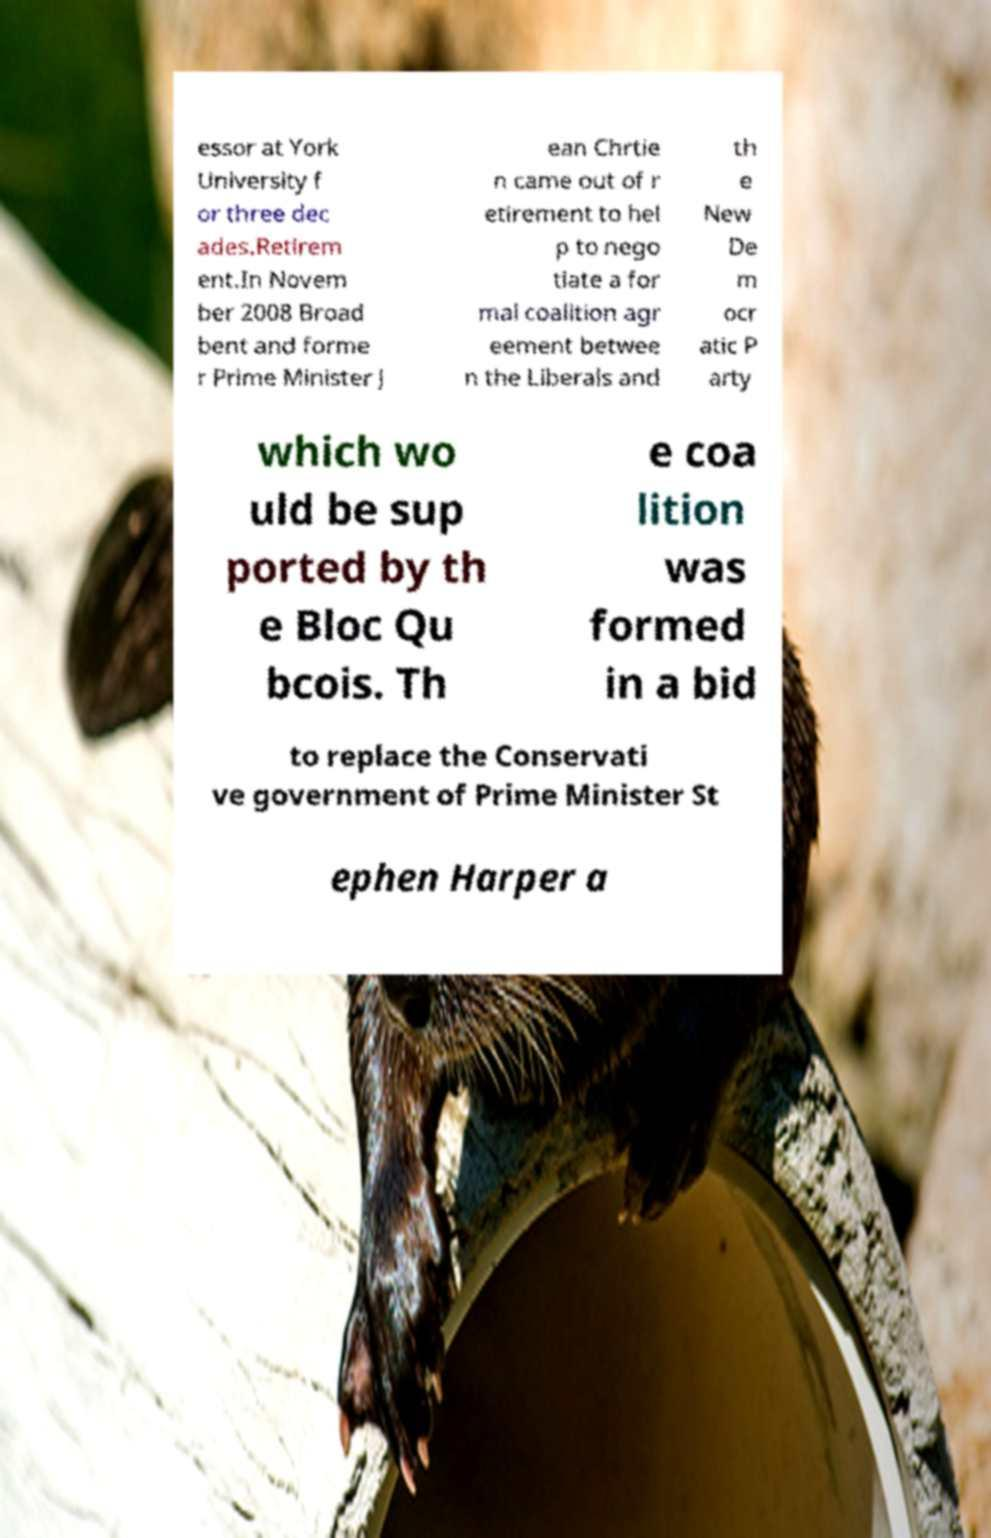There's text embedded in this image that I need extracted. Can you transcribe it verbatim? essor at York University f or three dec ades.Retirem ent.In Novem ber 2008 Broad bent and forme r Prime Minister J ean Chrtie n came out of r etirement to hel p to nego tiate a for mal coalition agr eement betwee n the Liberals and th e New De m ocr atic P arty which wo uld be sup ported by th e Bloc Qu bcois. Th e coa lition was formed in a bid to replace the Conservati ve government of Prime Minister St ephen Harper a 